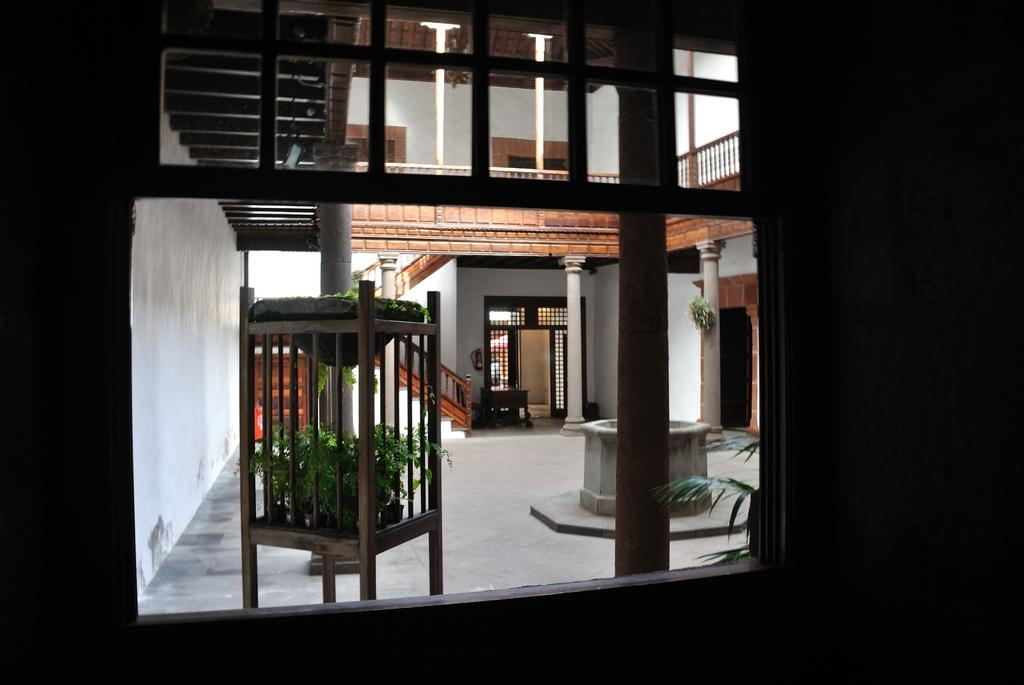Please provide a concise description of this image. In this image, we can see an inside view of a roof house. There are pillars in the middle of the image. There is a wooden cage at the bottom of the image contains some plants. There is a wall on the left side of the image. 